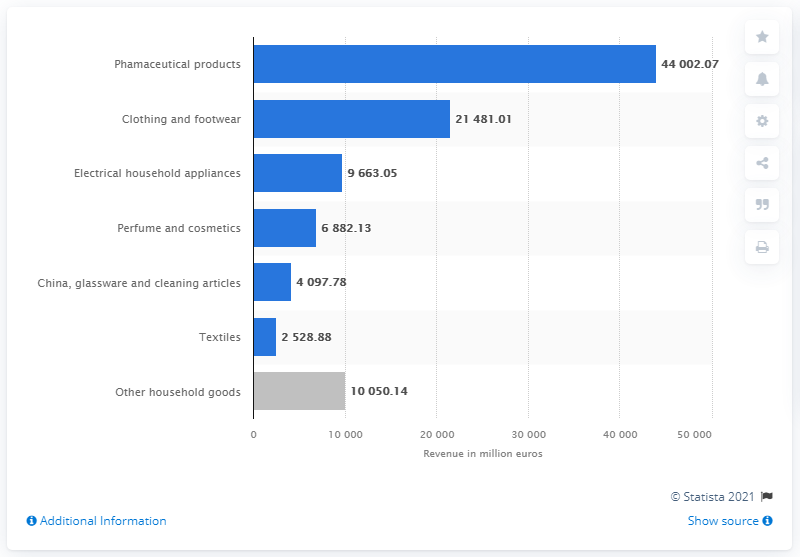Give some essential details in this illustration. In 2018, the wholesale of textiles reached a total of 2528.88. 